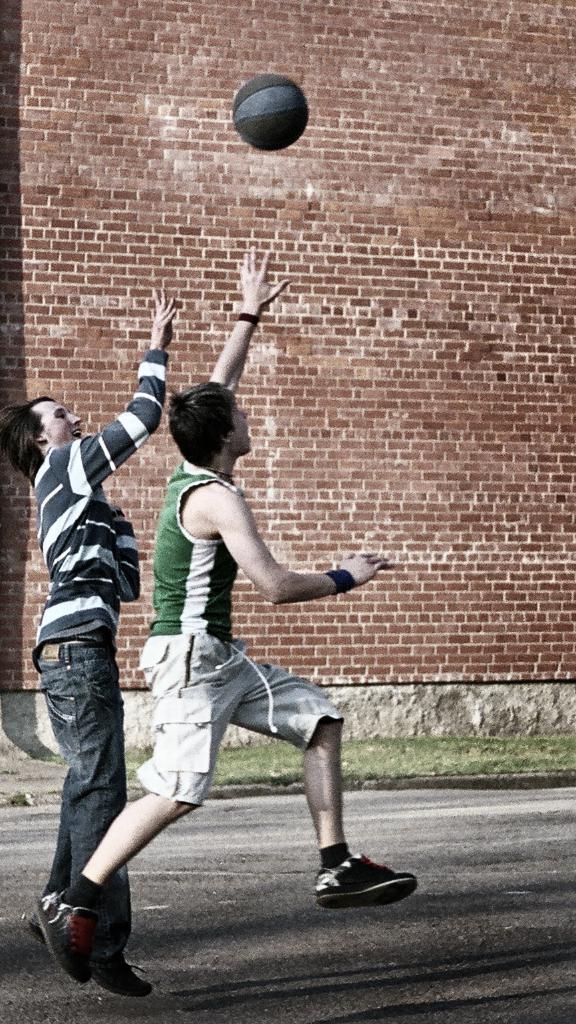Describe this image in one or two sentences. In this image we can see two boys are playing with ball. In the background of the image brick wall is there. 